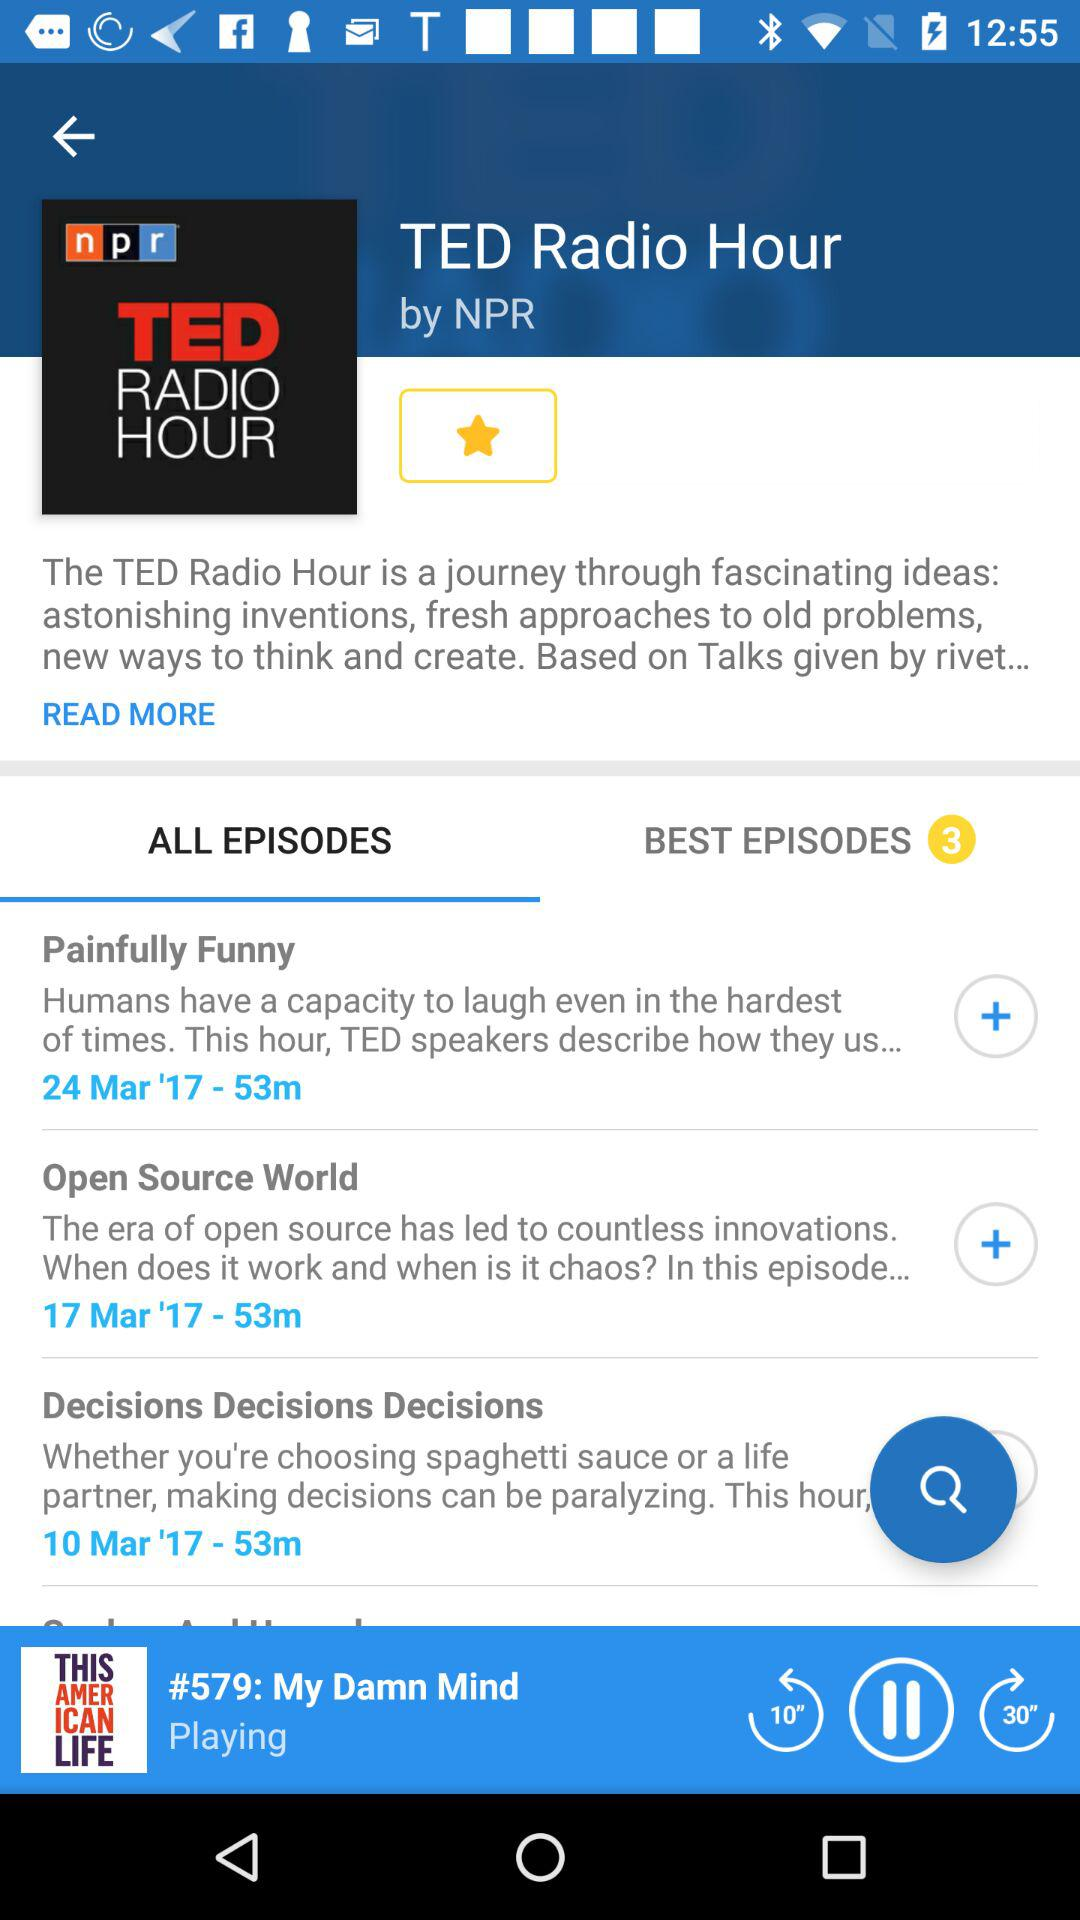Which episode is playing now? The episode playing is "My Damn Mind". 